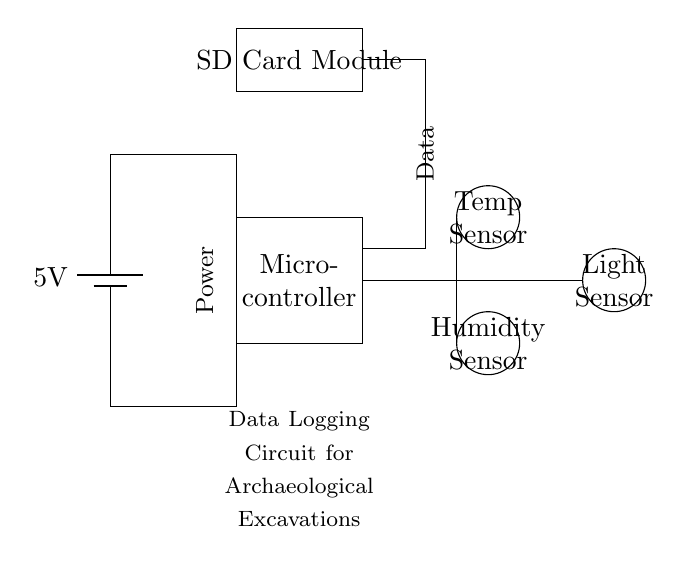What is the voltage of this circuit? The voltage is specified as 5V, which is indicated on the battery symbol in the circuit diagram. This symbol represents the power supply for the whole circuit.
Answer: 5V What type of microcontroller is used in this circuit? There is a microcontroller rectangle in the diagram, but it does not specify the exact type; it only indicates the general component as "Microcontroller". Therefore, the answer remains at a general level without further specification.
Answer: Microcontroller How many sensors are present in the circuit? There are three types of sensors shown: a temperature sensor, a humidity sensor, and a light sensor, which total three individual sensors present in the diagram.
Answer: Three What does the SD Card Module do in this circuit? The SD Card Module is a storage component which allows the recorded environmental data from the sensors to be saved for later analysis; this information is represented as being connected to the microcontroller in the diagram.
Answer: Storage Which sensor is located at the highest position in the diagram? The temperature sensor is drawn at the highest vertical position among the three sensors, as indicated by its placement within the circle above the rest.
Answer: Temperature sensor What is the purpose of the power supply in this circuit? The power supply provides the necessary 5V to operate all the components in the circuit, including the microcontroller and the sensors. It is essential for powering up the entire logging system to collect data effectively.
Answer: Powering components 